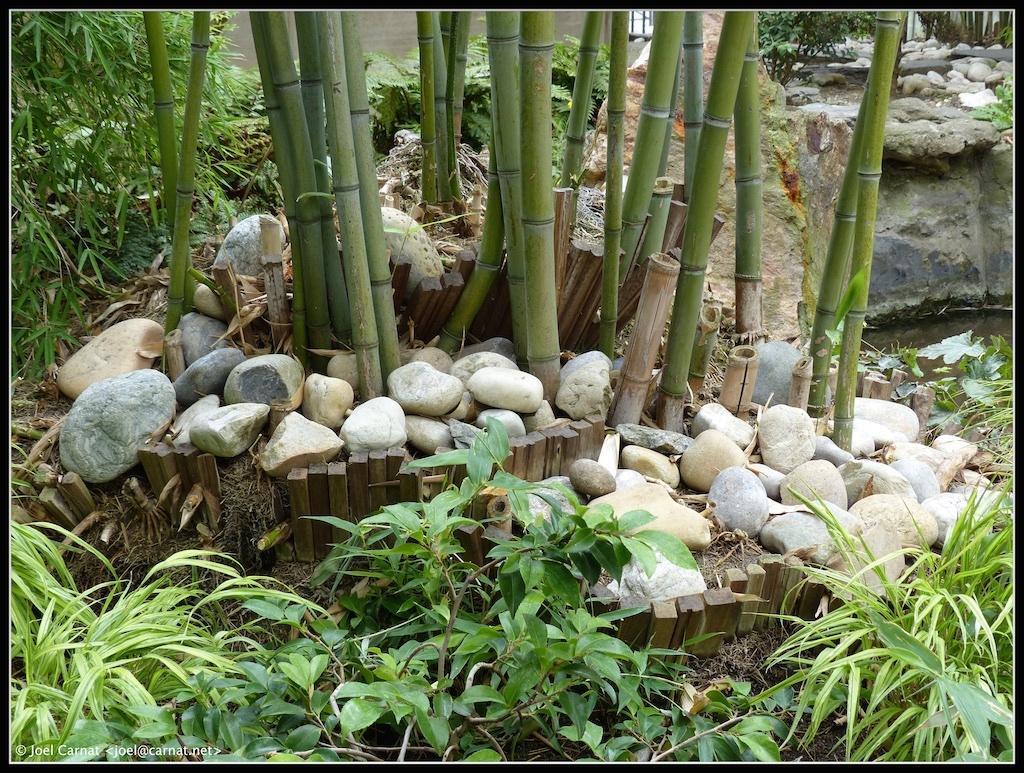How would you summarize this image in a sentence or two? In this image we can see some plants and there are some stones around the plants. On the right side, we can see a pond surrounded with plants. 